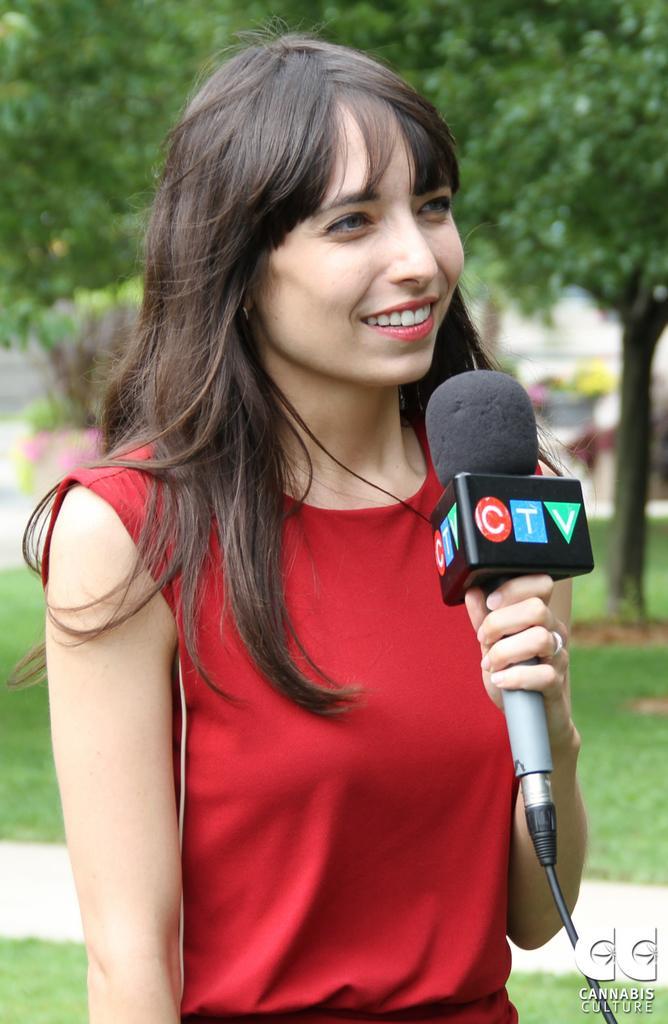Can you describe this image briefly? In the picture we can see a woman standing and talking in a microphone, she is smiling in the red dress, in the background we can see a trees, grass and a path. 